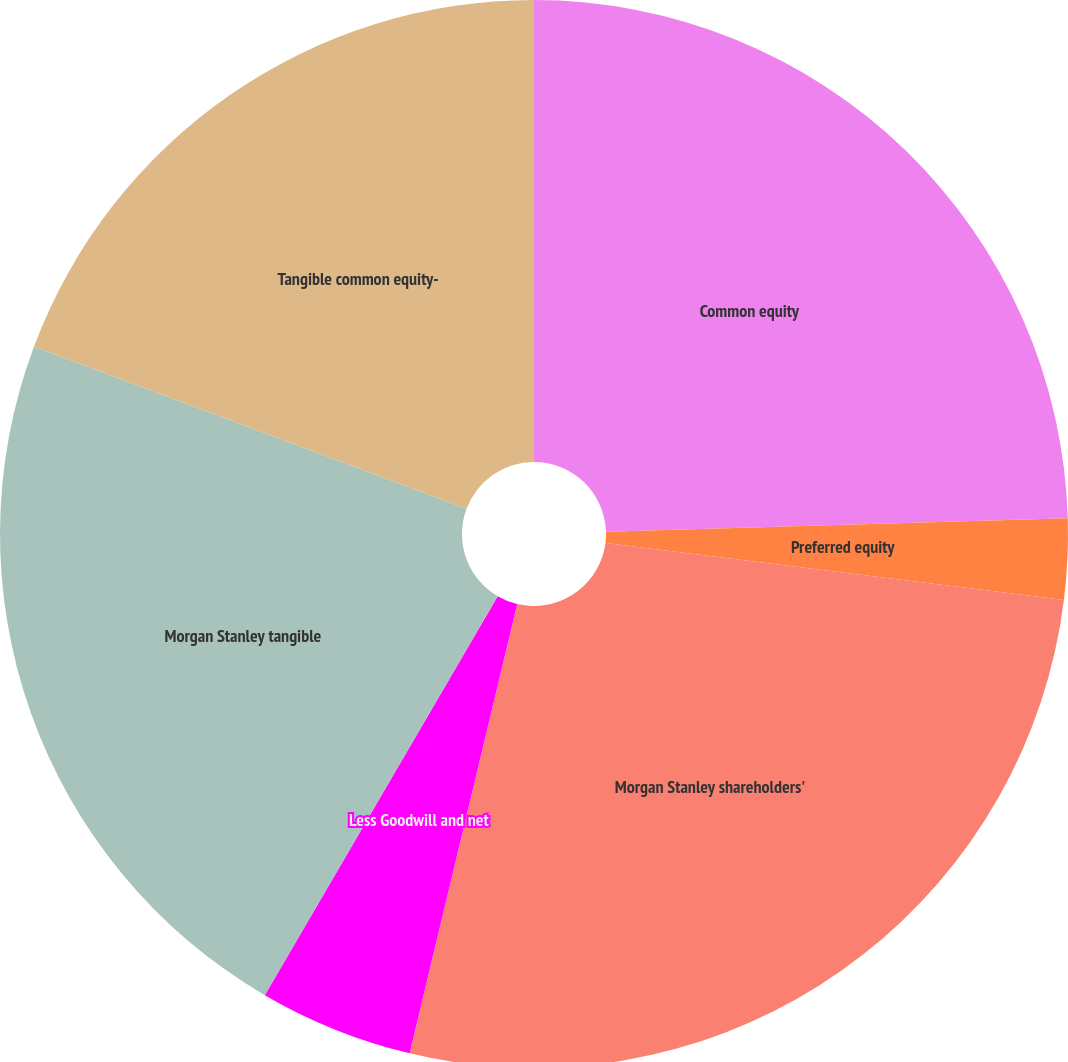<chart> <loc_0><loc_0><loc_500><loc_500><pie_chart><fcel>Common equity<fcel>Preferred equity<fcel>Morgan Stanley shareholders'<fcel>Less Goodwill and net<fcel>Morgan Stanley tangible<fcel>Tangible common equity-<nl><fcel>24.53%<fcel>2.44%<fcel>26.77%<fcel>4.67%<fcel>22.3%<fcel>19.29%<nl></chart> 